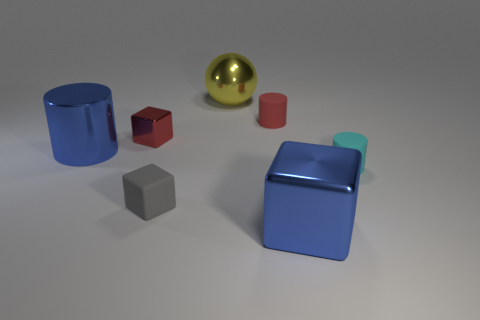Add 2 small cyan metallic cubes. How many objects exist? 9 Subtract all cyan cylinders. How many cylinders are left? 2 Subtract all balls. How many objects are left? 6 Subtract all purple blocks. Subtract all yellow cylinders. How many blocks are left? 3 Subtract all red metallic blocks. Subtract all red shiny blocks. How many objects are left? 5 Add 1 rubber cubes. How many rubber cubes are left? 2 Add 4 cyan matte objects. How many cyan matte objects exist? 5 Subtract 0 yellow cylinders. How many objects are left? 7 